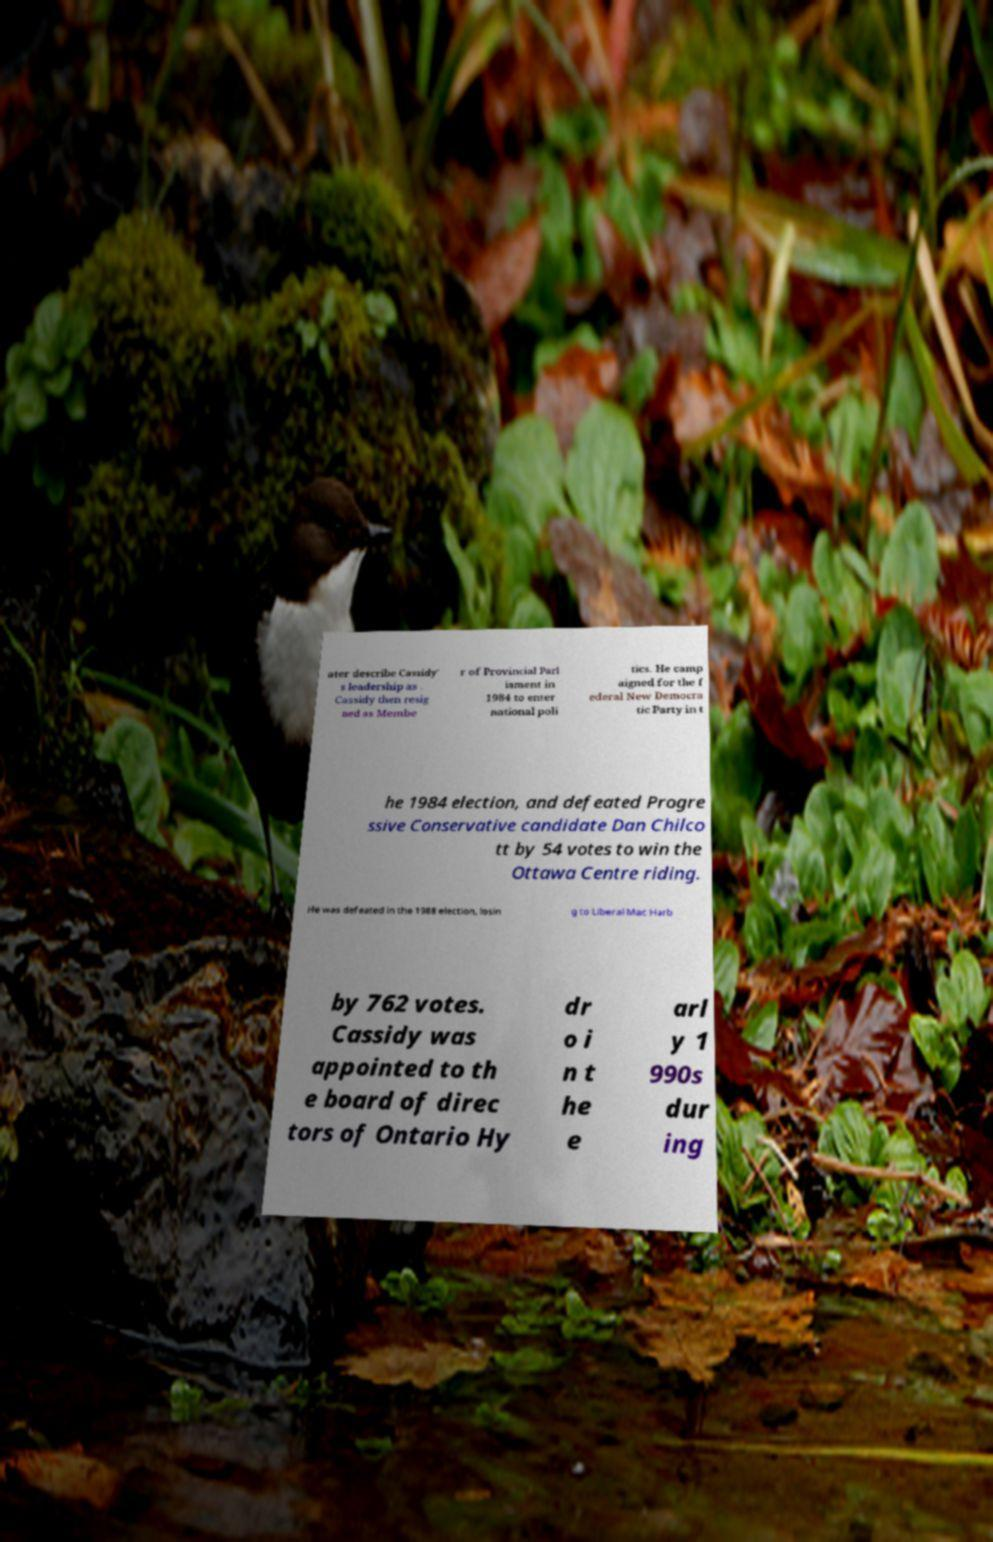Could you assist in decoding the text presented in this image and type it out clearly? ater describe Cassidy' s leadership as . Cassidy then resig ned as Membe r of Provincial Parl iament in 1984 to enter national poli tics. He camp aigned for the f ederal New Democra tic Party in t he 1984 election, and defeated Progre ssive Conservative candidate Dan Chilco tt by 54 votes to win the Ottawa Centre riding. He was defeated in the 1988 election, losin g to Liberal Mac Harb by 762 votes. Cassidy was appointed to th e board of direc tors of Ontario Hy dr o i n t he e arl y 1 990s dur ing 